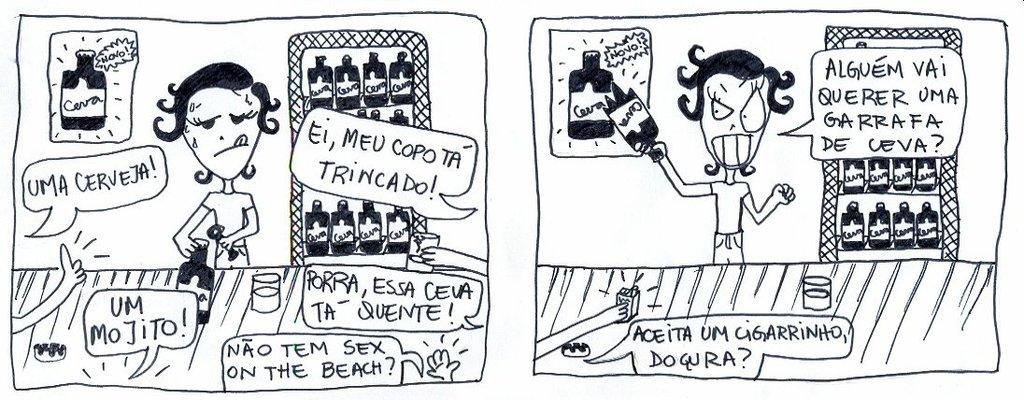What type of image is being described? The image is an animated picture. How many people are depicted in the image? There are two people drawn in the image. What additional elements are present in the image? Quotations are written around the pictures of the people. What type of ring can be seen on the finger of the person in the image? There is no ring visible on the finger of the person in the image. What is the opinion of the person in the image about the topic of the quotation? The image does not provide any information about the person's opinion on the topic of the quotation. 